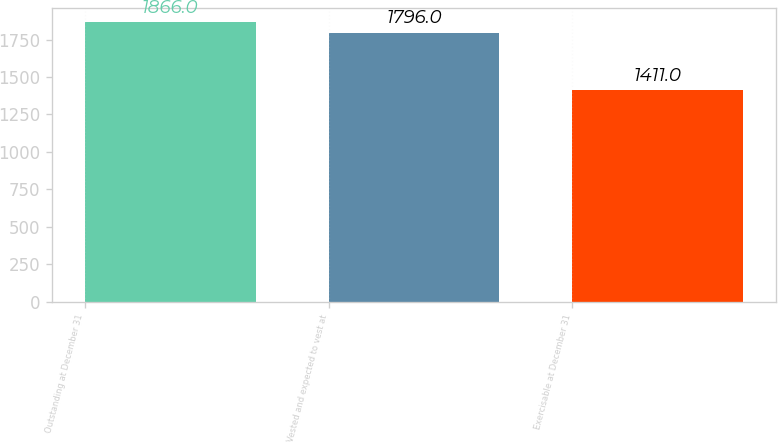<chart> <loc_0><loc_0><loc_500><loc_500><bar_chart><fcel>Outstanding at December 31<fcel>Vested and expected to vest at<fcel>Exercisable at December 31<nl><fcel>1866<fcel>1796<fcel>1411<nl></chart> 